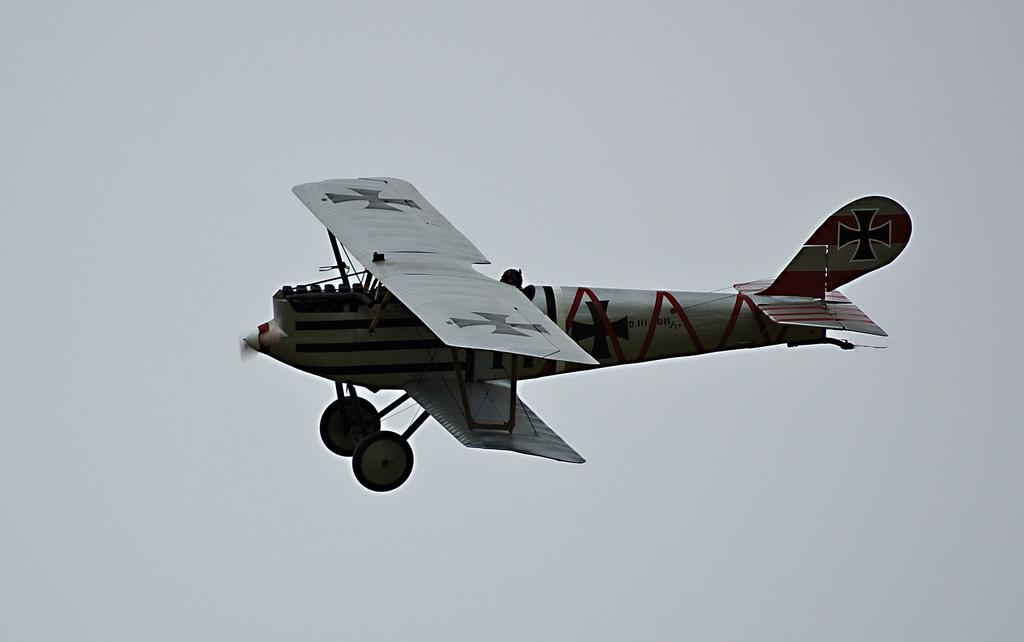What is the main subject of the image? There is an aircraft in the image. What is the aircraft doing in the image? The aircraft is flying in the air. What can be seen in the background of the image? The sky is visible in the background of the image. What word is written on the roof of the aircraft in the image? There is no word written on the roof of the aircraft in the image, as the roof is not visible. Can you see the heart of the pilot in the image? There is no pilot visible in the image, and even if there were, we cannot see their heart. 